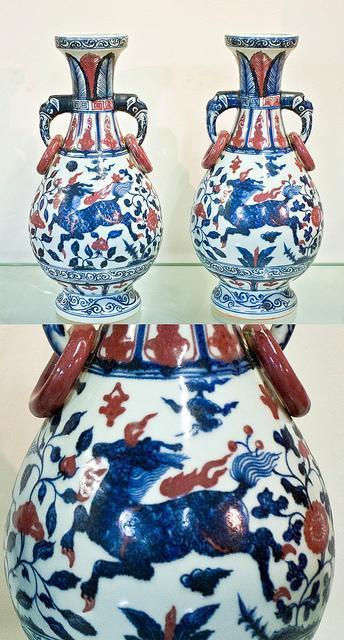How many vases are shown?
Give a very brief answer. 3. How many vases are there?
Give a very brief answer. 3. How many people can you see?
Give a very brief answer. 0. 